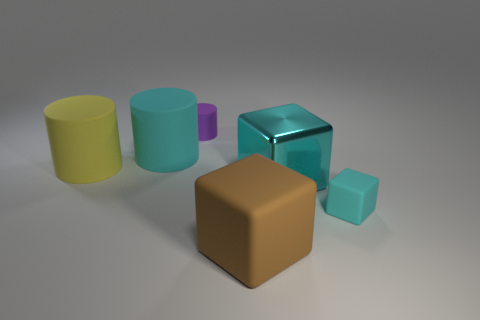What number of things are either matte cylinders or cyan blocks?
Offer a terse response. 5. Is there anything else that has the same material as the small cylinder?
Offer a terse response. Yes. Is the number of matte cylinders that are to the right of the tiny cylinder less than the number of small purple matte things?
Provide a short and direct response. Yes. Are there more cyan rubber things behind the tiny matte block than big rubber objects right of the tiny rubber cylinder?
Offer a terse response. No. Is there any other thing of the same color as the small cube?
Keep it short and to the point. Yes. What material is the cube behind the small cyan cube?
Give a very brief answer. Metal. Do the purple rubber thing and the brown matte thing have the same size?
Give a very brief answer. No. How many other objects are the same size as the yellow cylinder?
Keep it short and to the point. 3. Is the small matte cylinder the same color as the shiny thing?
Give a very brief answer. No. The big thing that is to the right of the large cube in front of the cyan matte object in front of the metal thing is what shape?
Give a very brief answer. Cube. 